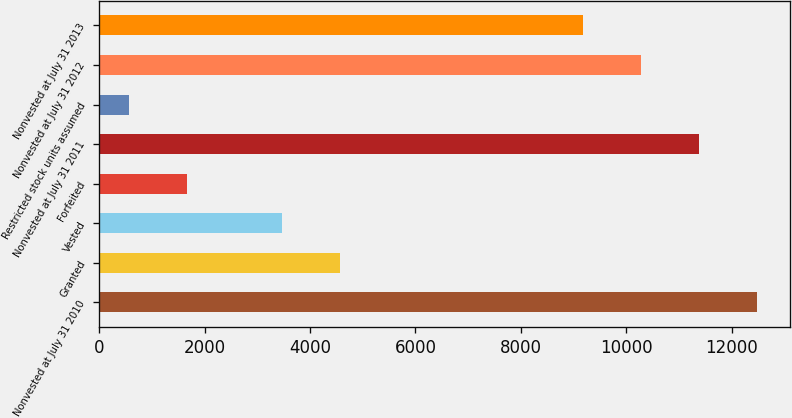Convert chart to OTSL. <chart><loc_0><loc_0><loc_500><loc_500><bar_chart><fcel>Nonvested at July 31 2010<fcel>Granted<fcel>Vested<fcel>Forfeited<fcel>Nonvested at July 31 2011<fcel>Restricted stock units assumed<fcel>Nonvested at July 31 2012<fcel>Nonvested at July 31 2013<nl><fcel>12470.8<fcel>4569.6<fcel>3474<fcel>1670.6<fcel>11375.2<fcel>575<fcel>10279.6<fcel>9184<nl></chart> 